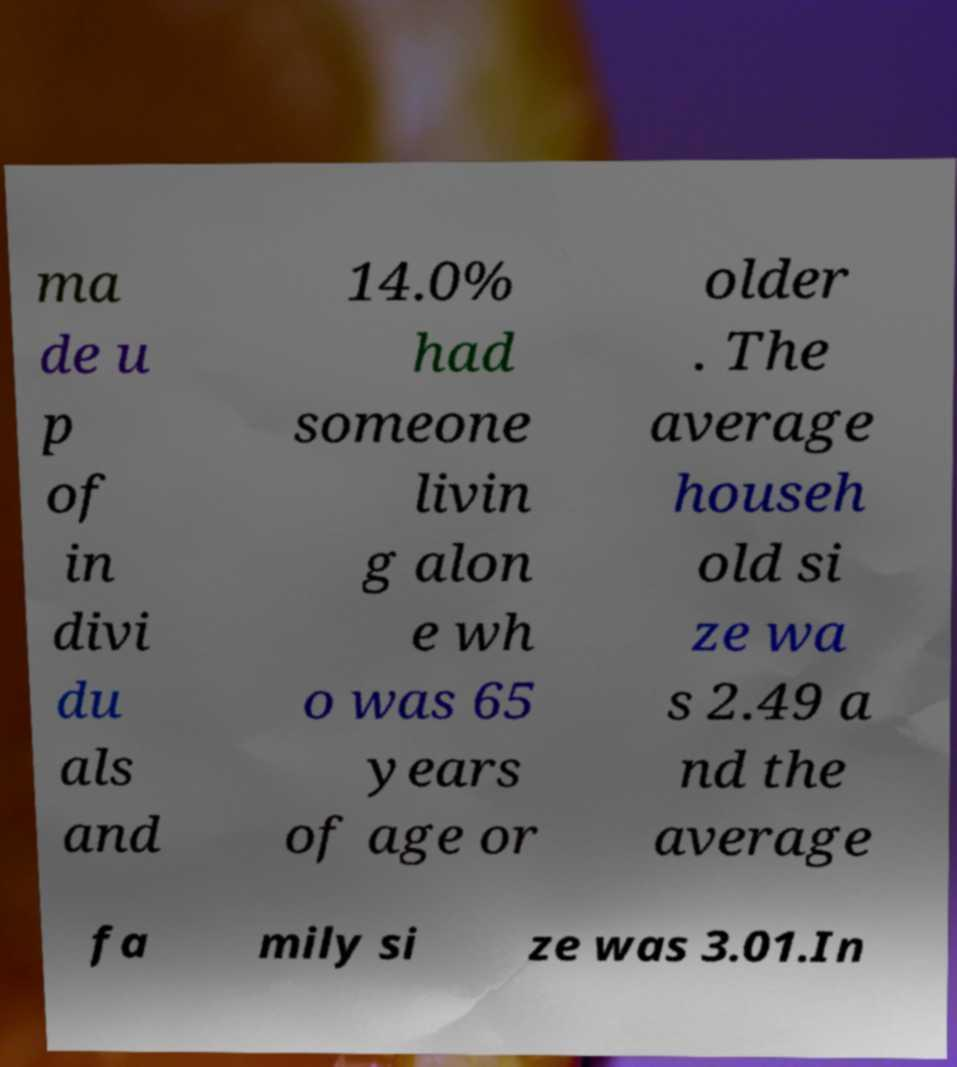Could you extract and type out the text from this image? ma de u p of in divi du als and 14.0% had someone livin g alon e wh o was 65 years of age or older . The average househ old si ze wa s 2.49 a nd the average fa mily si ze was 3.01.In 